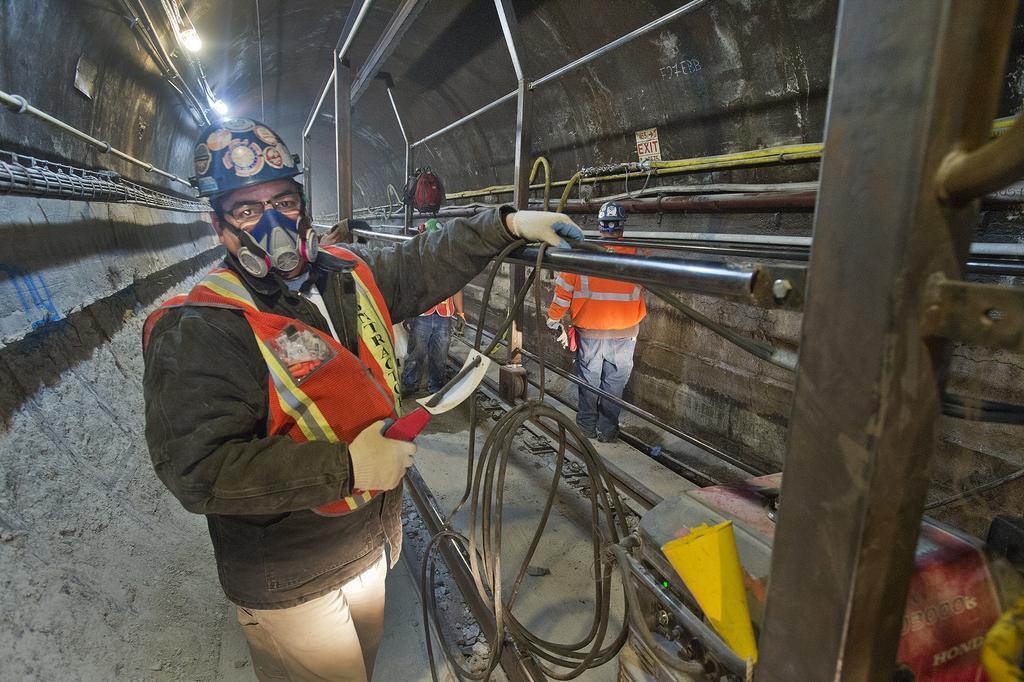Please provide a concise description of this image. In the image I can see a under ground place where we have some poles, people, machines and some other things around. 